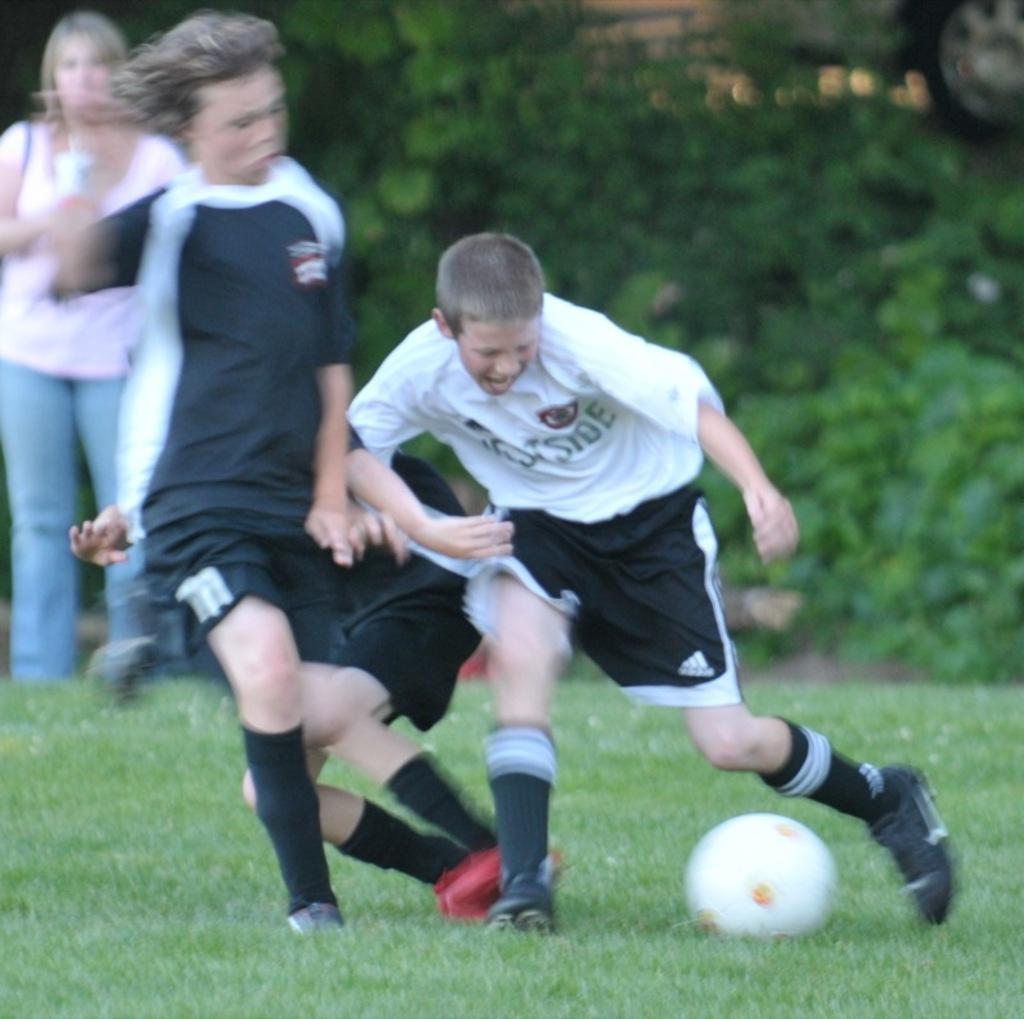Please provide a concise description of this image. In the foreground I can see three persons are playing a football on the ground. In the background I can see trees and a woman is standing. This image is taken during a day on the ground. 